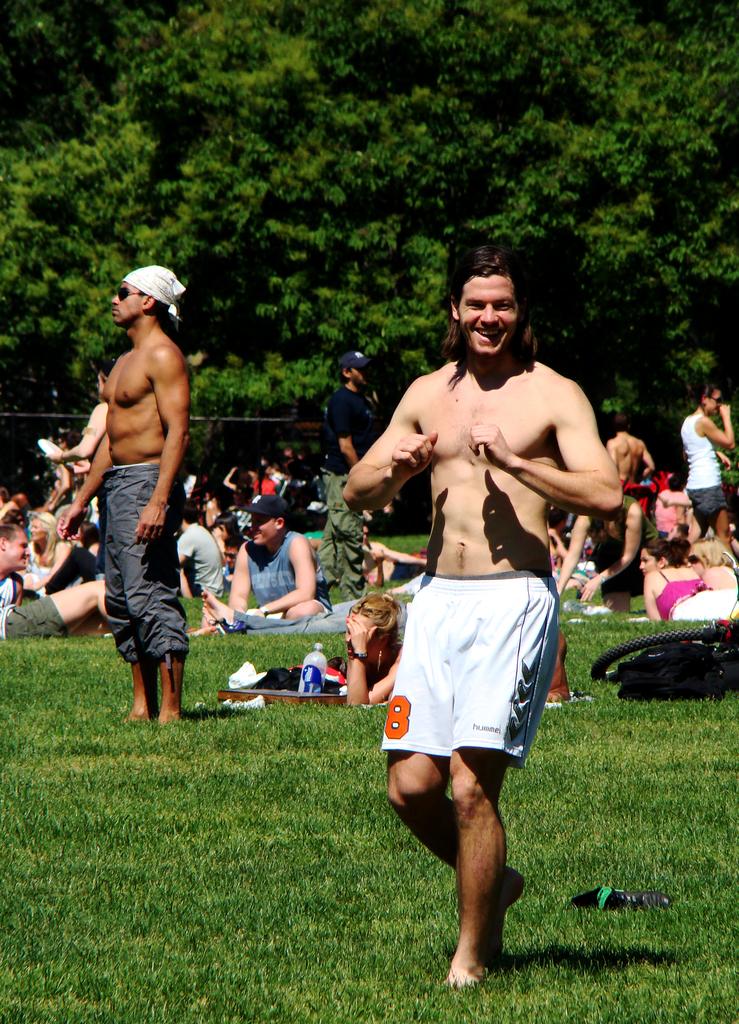What is the player's number?
Provide a succinct answer. 8. 